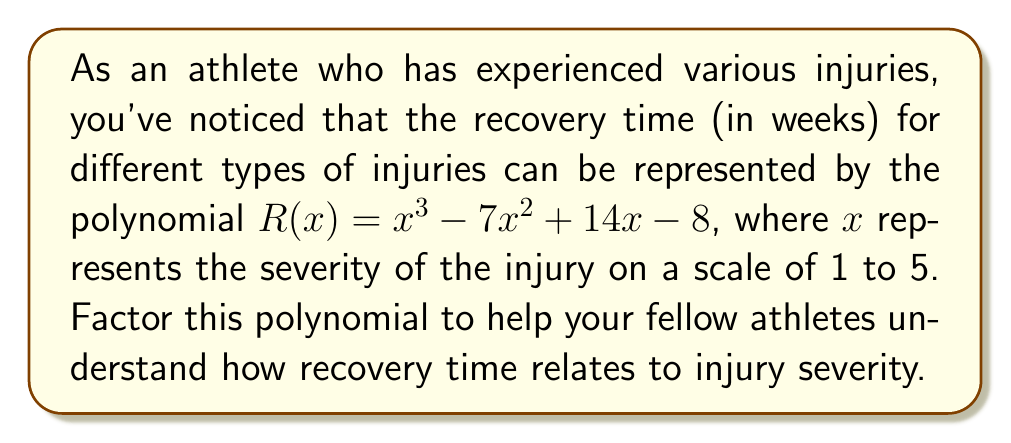Teach me how to tackle this problem. Let's factor the polynomial $R(x) = x^3 - 7x^2 + 14x - 8$ step by step:

1) First, let's check if there's a common factor. There isn't, so we move on.

2) This is a cubic polynomial. Let's try to find a root by guessing some factors of the constant term (-8). The possible factors are ±1, ±2, ±4, ±8.

3) Using the rational root theorem, we can test these values. Let's try x = 1:
   $R(1) = 1^3 - 7(1)^2 + 14(1) - 8 = 1 - 7 + 14 - 8 = 0$

4) We've found a root! x = 1 is a factor. So we can factor out (x - 1):
   $R(x) = (x - 1)(ax^2 + bx + c)$

5) To find a, b, and c, we can use polynomial long division or compare coefficients. Let's compare coefficients:
   $x^3 - 7x^2 + 14x - 8 = (x - 1)(x^2 + ax + b)$

6) Expanding the right side:
   $x^3 + ax^2 + bx - x^2 - ax - b = x^3 + (a-1)x^2 + (b-a)x - b$

7) Comparing coefficients:
   $a - 1 = -7$, so $a = -6$
   $b - a = 14$, so $b = 8$
   $-b = -8$, which confirms $b = 8$

8) Therefore, $R(x) = (x - 1)(x^2 - 6x + 8)$

9) The quadratic factor $x^2 - 6x + 8$ can be further factored:
   $(x - 2)(x - 4)$

10) Thus, the fully factored polynomial is:
    $R(x) = (x - 1)(x - 2)(x - 4)$

This factorization shows that the recovery time is zero when the injury severity (x) is 1, 2, or 4 on the scale, which represents the quickest recovery times for different levels of injury severity.
Answer: $(x - 1)(x - 2)(x - 4)$ 